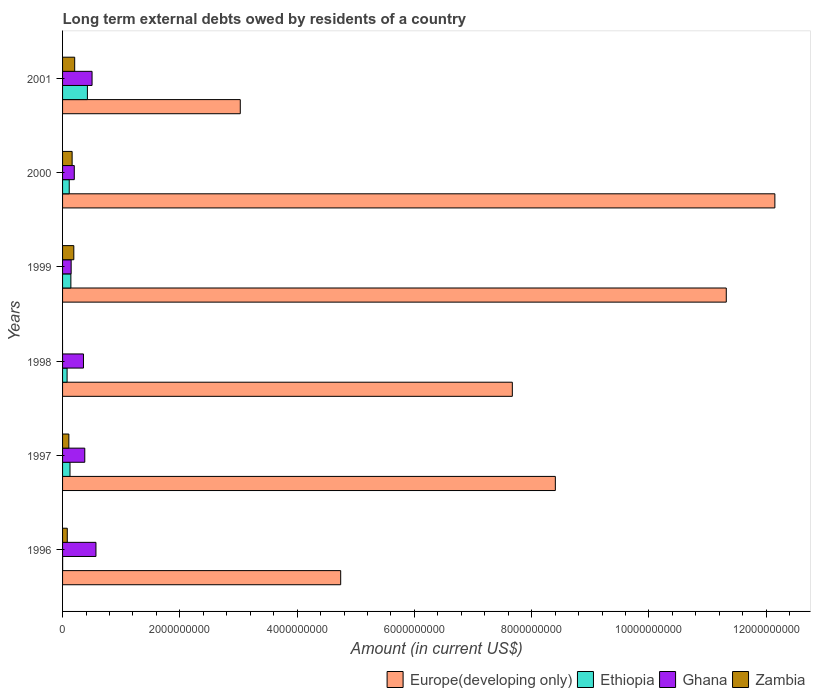How many groups of bars are there?
Offer a very short reply. 6. How many bars are there on the 6th tick from the top?
Keep it short and to the point. 4. How many bars are there on the 3rd tick from the bottom?
Ensure brevity in your answer.  3. Across all years, what is the maximum amount of long-term external debts owed by residents in Ghana?
Keep it short and to the point. 5.69e+08. Across all years, what is the minimum amount of long-term external debts owed by residents in Europe(developing only)?
Your answer should be compact. 3.03e+09. In which year was the amount of long-term external debts owed by residents in Zambia maximum?
Your answer should be very brief. 2001. What is the total amount of long-term external debts owed by residents in Ghana in the graph?
Ensure brevity in your answer.  2.15e+09. What is the difference between the amount of long-term external debts owed by residents in Zambia in 1997 and that in 2001?
Provide a succinct answer. -9.94e+07. What is the difference between the amount of long-term external debts owed by residents in Ethiopia in 2000 and the amount of long-term external debts owed by residents in Europe(developing only) in 1998?
Your answer should be compact. -7.56e+09. What is the average amount of long-term external debts owed by residents in Zambia per year?
Your answer should be very brief. 1.25e+08. In the year 1999, what is the difference between the amount of long-term external debts owed by residents in Europe(developing only) and amount of long-term external debts owed by residents in Ethiopia?
Offer a very short reply. 1.12e+1. In how many years, is the amount of long-term external debts owed by residents in Zambia greater than 5600000000 US$?
Provide a short and direct response. 0. What is the ratio of the amount of long-term external debts owed by residents in Zambia in 1999 to that in 2001?
Provide a succinct answer. 0.93. What is the difference between the highest and the second highest amount of long-term external debts owed by residents in Zambia?
Your response must be concise. 1.48e+07. What is the difference between the highest and the lowest amount of long-term external debts owed by residents in Europe(developing only)?
Keep it short and to the point. 9.12e+09. Is it the case that in every year, the sum of the amount of long-term external debts owed by residents in Europe(developing only) and amount of long-term external debts owed by residents in Ethiopia is greater than the sum of amount of long-term external debts owed by residents in Ghana and amount of long-term external debts owed by residents in Zambia?
Your response must be concise. Yes. Is it the case that in every year, the sum of the amount of long-term external debts owed by residents in Ethiopia and amount of long-term external debts owed by residents in Europe(developing only) is greater than the amount of long-term external debts owed by residents in Ghana?
Give a very brief answer. Yes. What is the difference between two consecutive major ticks on the X-axis?
Make the answer very short. 2.00e+09. Does the graph contain any zero values?
Provide a succinct answer. Yes. What is the title of the graph?
Make the answer very short. Long term external debts owed by residents of a country. Does "Paraguay" appear as one of the legend labels in the graph?
Offer a very short reply. No. What is the label or title of the X-axis?
Provide a short and direct response. Amount (in current US$). What is the label or title of the Y-axis?
Provide a succinct answer. Years. What is the Amount (in current US$) in Europe(developing only) in 1996?
Give a very brief answer. 4.74e+09. What is the Amount (in current US$) of Ethiopia in 1996?
Keep it short and to the point. 8.89e+05. What is the Amount (in current US$) of Ghana in 1996?
Your answer should be compact. 5.69e+08. What is the Amount (in current US$) in Zambia in 1996?
Your response must be concise. 8.04e+07. What is the Amount (in current US$) in Europe(developing only) in 1997?
Give a very brief answer. 8.40e+09. What is the Amount (in current US$) of Ethiopia in 1997?
Make the answer very short. 1.27e+08. What is the Amount (in current US$) of Ghana in 1997?
Provide a short and direct response. 3.79e+08. What is the Amount (in current US$) in Zambia in 1997?
Provide a succinct answer. 1.07e+08. What is the Amount (in current US$) of Europe(developing only) in 1998?
Your answer should be very brief. 7.67e+09. What is the Amount (in current US$) of Ethiopia in 1998?
Keep it short and to the point. 7.71e+07. What is the Amount (in current US$) in Ghana in 1998?
Keep it short and to the point. 3.57e+08. What is the Amount (in current US$) of Europe(developing only) in 1999?
Offer a terse response. 1.13e+1. What is the Amount (in current US$) of Ethiopia in 1999?
Your answer should be very brief. 1.42e+08. What is the Amount (in current US$) of Ghana in 1999?
Your response must be concise. 1.46e+08. What is the Amount (in current US$) of Zambia in 1999?
Your answer should be compact. 1.92e+08. What is the Amount (in current US$) of Europe(developing only) in 2000?
Ensure brevity in your answer.  1.21e+1. What is the Amount (in current US$) of Ethiopia in 2000?
Your response must be concise. 1.14e+08. What is the Amount (in current US$) in Ghana in 2000?
Ensure brevity in your answer.  2.00e+08. What is the Amount (in current US$) of Zambia in 2000?
Give a very brief answer. 1.63e+08. What is the Amount (in current US$) in Europe(developing only) in 2001?
Your answer should be compact. 3.03e+09. What is the Amount (in current US$) of Ethiopia in 2001?
Provide a succinct answer. 4.24e+08. What is the Amount (in current US$) in Ghana in 2001?
Give a very brief answer. 5.03e+08. What is the Amount (in current US$) in Zambia in 2001?
Your answer should be very brief. 2.07e+08. Across all years, what is the maximum Amount (in current US$) in Europe(developing only)?
Provide a succinct answer. 1.21e+1. Across all years, what is the maximum Amount (in current US$) in Ethiopia?
Your answer should be very brief. 4.24e+08. Across all years, what is the maximum Amount (in current US$) in Ghana?
Offer a terse response. 5.69e+08. Across all years, what is the maximum Amount (in current US$) of Zambia?
Give a very brief answer. 2.07e+08. Across all years, what is the minimum Amount (in current US$) of Europe(developing only)?
Offer a terse response. 3.03e+09. Across all years, what is the minimum Amount (in current US$) of Ethiopia?
Offer a very short reply. 8.89e+05. Across all years, what is the minimum Amount (in current US$) in Ghana?
Your response must be concise. 1.46e+08. What is the total Amount (in current US$) in Europe(developing only) in the graph?
Keep it short and to the point. 4.73e+1. What is the total Amount (in current US$) in Ethiopia in the graph?
Ensure brevity in your answer.  8.84e+08. What is the total Amount (in current US$) in Ghana in the graph?
Make the answer very short. 2.15e+09. What is the total Amount (in current US$) in Zambia in the graph?
Keep it short and to the point. 7.49e+08. What is the difference between the Amount (in current US$) in Europe(developing only) in 1996 and that in 1997?
Make the answer very short. -3.66e+09. What is the difference between the Amount (in current US$) of Ethiopia in 1996 and that in 1997?
Your response must be concise. -1.26e+08. What is the difference between the Amount (in current US$) of Ghana in 1996 and that in 1997?
Make the answer very short. 1.91e+08. What is the difference between the Amount (in current US$) of Zambia in 1996 and that in 1997?
Provide a short and direct response. -2.69e+07. What is the difference between the Amount (in current US$) of Europe(developing only) in 1996 and that in 1998?
Your response must be concise. -2.93e+09. What is the difference between the Amount (in current US$) of Ethiopia in 1996 and that in 1998?
Your answer should be compact. -7.62e+07. What is the difference between the Amount (in current US$) in Ghana in 1996 and that in 1998?
Offer a very short reply. 2.13e+08. What is the difference between the Amount (in current US$) of Europe(developing only) in 1996 and that in 1999?
Provide a succinct answer. -6.58e+09. What is the difference between the Amount (in current US$) in Ethiopia in 1996 and that in 1999?
Your response must be concise. -1.41e+08. What is the difference between the Amount (in current US$) of Ghana in 1996 and that in 1999?
Your response must be concise. 4.23e+08. What is the difference between the Amount (in current US$) in Zambia in 1996 and that in 1999?
Your answer should be very brief. -1.11e+08. What is the difference between the Amount (in current US$) in Europe(developing only) in 1996 and that in 2000?
Provide a short and direct response. -7.41e+09. What is the difference between the Amount (in current US$) of Ethiopia in 1996 and that in 2000?
Provide a short and direct response. -1.13e+08. What is the difference between the Amount (in current US$) in Ghana in 1996 and that in 2000?
Give a very brief answer. 3.69e+08. What is the difference between the Amount (in current US$) of Zambia in 1996 and that in 2000?
Give a very brief answer. -8.26e+07. What is the difference between the Amount (in current US$) in Europe(developing only) in 1996 and that in 2001?
Provide a succinct answer. 1.71e+09. What is the difference between the Amount (in current US$) in Ethiopia in 1996 and that in 2001?
Offer a terse response. -4.23e+08. What is the difference between the Amount (in current US$) in Ghana in 1996 and that in 2001?
Ensure brevity in your answer.  6.64e+07. What is the difference between the Amount (in current US$) in Zambia in 1996 and that in 2001?
Make the answer very short. -1.26e+08. What is the difference between the Amount (in current US$) of Europe(developing only) in 1997 and that in 1998?
Ensure brevity in your answer.  7.33e+08. What is the difference between the Amount (in current US$) of Ethiopia in 1997 and that in 1998?
Offer a very short reply. 4.96e+07. What is the difference between the Amount (in current US$) in Ghana in 1997 and that in 1998?
Provide a succinct answer. 2.22e+07. What is the difference between the Amount (in current US$) in Europe(developing only) in 1997 and that in 1999?
Offer a terse response. -2.92e+09. What is the difference between the Amount (in current US$) in Ethiopia in 1997 and that in 1999?
Your answer should be very brief. -1.51e+07. What is the difference between the Amount (in current US$) in Ghana in 1997 and that in 1999?
Give a very brief answer. 2.32e+08. What is the difference between the Amount (in current US$) in Zambia in 1997 and that in 1999?
Make the answer very short. -8.45e+07. What is the difference between the Amount (in current US$) in Europe(developing only) in 1997 and that in 2000?
Your answer should be very brief. -3.74e+09. What is the difference between the Amount (in current US$) in Ethiopia in 1997 and that in 2000?
Your answer should be very brief. 1.30e+07. What is the difference between the Amount (in current US$) of Ghana in 1997 and that in 2000?
Your answer should be compact. 1.79e+08. What is the difference between the Amount (in current US$) of Zambia in 1997 and that in 2000?
Keep it short and to the point. -5.57e+07. What is the difference between the Amount (in current US$) in Europe(developing only) in 1997 and that in 2001?
Make the answer very short. 5.37e+09. What is the difference between the Amount (in current US$) in Ethiopia in 1997 and that in 2001?
Keep it short and to the point. -2.97e+08. What is the difference between the Amount (in current US$) in Ghana in 1997 and that in 2001?
Your answer should be compact. -1.24e+08. What is the difference between the Amount (in current US$) of Zambia in 1997 and that in 2001?
Offer a very short reply. -9.94e+07. What is the difference between the Amount (in current US$) in Europe(developing only) in 1998 and that in 1999?
Provide a short and direct response. -3.65e+09. What is the difference between the Amount (in current US$) in Ethiopia in 1998 and that in 1999?
Your response must be concise. -6.47e+07. What is the difference between the Amount (in current US$) of Ghana in 1998 and that in 1999?
Provide a short and direct response. 2.10e+08. What is the difference between the Amount (in current US$) of Europe(developing only) in 1998 and that in 2000?
Make the answer very short. -4.48e+09. What is the difference between the Amount (in current US$) in Ethiopia in 1998 and that in 2000?
Your answer should be compact. -3.66e+07. What is the difference between the Amount (in current US$) in Ghana in 1998 and that in 2000?
Make the answer very short. 1.57e+08. What is the difference between the Amount (in current US$) of Europe(developing only) in 1998 and that in 2001?
Make the answer very short. 4.64e+09. What is the difference between the Amount (in current US$) in Ethiopia in 1998 and that in 2001?
Keep it short and to the point. -3.46e+08. What is the difference between the Amount (in current US$) in Ghana in 1998 and that in 2001?
Make the answer very short. -1.46e+08. What is the difference between the Amount (in current US$) in Europe(developing only) in 1999 and that in 2000?
Your response must be concise. -8.29e+08. What is the difference between the Amount (in current US$) of Ethiopia in 1999 and that in 2000?
Offer a terse response. 2.81e+07. What is the difference between the Amount (in current US$) of Ghana in 1999 and that in 2000?
Offer a very short reply. -5.35e+07. What is the difference between the Amount (in current US$) in Zambia in 1999 and that in 2000?
Give a very brief answer. 2.88e+07. What is the difference between the Amount (in current US$) of Europe(developing only) in 1999 and that in 2001?
Keep it short and to the point. 8.29e+09. What is the difference between the Amount (in current US$) in Ethiopia in 1999 and that in 2001?
Provide a succinct answer. -2.82e+08. What is the difference between the Amount (in current US$) in Ghana in 1999 and that in 2001?
Provide a succinct answer. -3.57e+08. What is the difference between the Amount (in current US$) in Zambia in 1999 and that in 2001?
Offer a very short reply. -1.48e+07. What is the difference between the Amount (in current US$) of Europe(developing only) in 2000 and that in 2001?
Offer a terse response. 9.12e+09. What is the difference between the Amount (in current US$) of Ethiopia in 2000 and that in 2001?
Provide a short and direct response. -3.10e+08. What is the difference between the Amount (in current US$) in Ghana in 2000 and that in 2001?
Make the answer very short. -3.03e+08. What is the difference between the Amount (in current US$) in Zambia in 2000 and that in 2001?
Make the answer very short. -4.37e+07. What is the difference between the Amount (in current US$) of Europe(developing only) in 1996 and the Amount (in current US$) of Ethiopia in 1997?
Offer a very short reply. 4.62e+09. What is the difference between the Amount (in current US$) of Europe(developing only) in 1996 and the Amount (in current US$) of Ghana in 1997?
Provide a short and direct response. 4.36e+09. What is the difference between the Amount (in current US$) in Europe(developing only) in 1996 and the Amount (in current US$) in Zambia in 1997?
Give a very brief answer. 4.64e+09. What is the difference between the Amount (in current US$) of Ethiopia in 1996 and the Amount (in current US$) of Ghana in 1997?
Provide a succinct answer. -3.78e+08. What is the difference between the Amount (in current US$) in Ethiopia in 1996 and the Amount (in current US$) in Zambia in 1997?
Make the answer very short. -1.06e+08. What is the difference between the Amount (in current US$) of Ghana in 1996 and the Amount (in current US$) of Zambia in 1997?
Your answer should be compact. 4.62e+08. What is the difference between the Amount (in current US$) in Europe(developing only) in 1996 and the Amount (in current US$) in Ethiopia in 1998?
Offer a terse response. 4.67e+09. What is the difference between the Amount (in current US$) of Europe(developing only) in 1996 and the Amount (in current US$) of Ghana in 1998?
Your response must be concise. 4.39e+09. What is the difference between the Amount (in current US$) of Ethiopia in 1996 and the Amount (in current US$) of Ghana in 1998?
Ensure brevity in your answer.  -3.56e+08. What is the difference between the Amount (in current US$) of Europe(developing only) in 1996 and the Amount (in current US$) of Ethiopia in 1999?
Your answer should be compact. 4.60e+09. What is the difference between the Amount (in current US$) in Europe(developing only) in 1996 and the Amount (in current US$) in Ghana in 1999?
Make the answer very short. 4.60e+09. What is the difference between the Amount (in current US$) of Europe(developing only) in 1996 and the Amount (in current US$) of Zambia in 1999?
Your response must be concise. 4.55e+09. What is the difference between the Amount (in current US$) in Ethiopia in 1996 and the Amount (in current US$) in Ghana in 1999?
Make the answer very short. -1.46e+08. What is the difference between the Amount (in current US$) in Ethiopia in 1996 and the Amount (in current US$) in Zambia in 1999?
Provide a short and direct response. -1.91e+08. What is the difference between the Amount (in current US$) in Ghana in 1996 and the Amount (in current US$) in Zambia in 1999?
Your response must be concise. 3.77e+08. What is the difference between the Amount (in current US$) of Europe(developing only) in 1996 and the Amount (in current US$) of Ethiopia in 2000?
Provide a short and direct response. 4.63e+09. What is the difference between the Amount (in current US$) in Europe(developing only) in 1996 and the Amount (in current US$) in Ghana in 2000?
Give a very brief answer. 4.54e+09. What is the difference between the Amount (in current US$) in Europe(developing only) in 1996 and the Amount (in current US$) in Zambia in 2000?
Give a very brief answer. 4.58e+09. What is the difference between the Amount (in current US$) in Ethiopia in 1996 and the Amount (in current US$) in Ghana in 2000?
Provide a short and direct response. -1.99e+08. What is the difference between the Amount (in current US$) in Ethiopia in 1996 and the Amount (in current US$) in Zambia in 2000?
Make the answer very short. -1.62e+08. What is the difference between the Amount (in current US$) of Ghana in 1996 and the Amount (in current US$) of Zambia in 2000?
Ensure brevity in your answer.  4.06e+08. What is the difference between the Amount (in current US$) of Europe(developing only) in 1996 and the Amount (in current US$) of Ethiopia in 2001?
Your answer should be very brief. 4.32e+09. What is the difference between the Amount (in current US$) in Europe(developing only) in 1996 and the Amount (in current US$) in Ghana in 2001?
Your response must be concise. 4.24e+09. What is the difference between the Amount (in current US$) of Europe(developing only) in 1996 and the Amount (in current US$) of Zambia in 2001?
Your answer should be very brief. 4.54e+09. What is the difference between the Amount (in current US$) in Ethiopia in 1996 and the Amount (in current US$) in Ghana in 2001?
Offer a terse response. -5.02e+08. What is the difference between the Amount (in current US$) of Ethiopia in 1996 and the Amount (in current US$) of Zambia in 2001?
Offer a terse response. -2.06e+08. What is the difference between the Amount (in current US$) of Ghana in 1996 and the Amount (in current US$) of Zambia in 2001?
Keep it short and to the point. 3.63e+08. What is the difference between the Amount (in current US$) in Europe(developing only) in 1997 and the Amount (in current US$) in Ethiopia in 1998?
Offer a terse response. 8.33e+09. What is the difference between the Amount (in current US$) of Europe(developing only) in 1997 and the Amount (in current US$) of Ghana in 1998?
Provide a short and direct response. 8.05e+09. What is the difference between the Amount (in current US$) in Ethiopia in 1997 and the Amount (in current US$) in Ghana in 1998?
Your response must be concise. -2.30e+08. What is the difference between the Amount (in current US$) of Europe(developing only) in 1997 and the Amount (in current US$) of Ethiopia in 1999?
Your answer should be very brief. 8.26e+09. What is the difference between the Amount (in current US$) in Europe(developing only) in 1997 and the Amount (in current US$) in Ghana in 1999?
Offer a terse response. 8.26e+09. What is the difference between the Amount (in current US$) of Europe(developing only) in 1997 and the Amount (in current US$) of Zambia in 1999?
Give a very brief answer. 8.21e+09. What is the difference between the Amount (in current US$) in Ethiopia in 1997 and the Amount (in current US$) in Ghana in 1999?
Your answer should be very brief. -1.97e+07. What is the difference between the Amount (in current US$) of Ethiopia in 1997 and the Amount (in current US$) of Zambia in 1999?
Provide a succinct answer. -6.51e+07. What is the difference between the Amount (in current US$) in Ghana in 1997 and the Amount (in current US$) in Zambia in 1999?
Your answer should be compact. 1.87e+08. What is the difference between the Amount (in current US$) in Europe(developing only) in 1997 and the Amount (in current US$) in Ethiopia in 2000?
Make the answer very short. 8.29e+09. What is the difference between the Amount (in current US$) of Europe(developing only) in 1997 and the Amount (in current US$) of Ghana in 2000?
Your response must be concise. 8.20e+09. What is the difference between the Amount (in current US$) in Europe(developing only) in 1997 and the Amount (in current US$) in Zambia in 2000?
Keep it short and to the point. 8.24e+09. What is the difference between the Amount (in current US$) of Ethiopia in 1997 and the Amount (in current US$) of Ghana in 2000?
Keep it short and to the point. -7.31e+07. What is the difference between the Amount (in current US$) of Ethiopia in 1997 and the Amount (in current US$) of Zambia in 2000?
Offer a terse response. -3.63e+07. What is the difference between the Amount (in current US$) in Ghana in 1997 and the Amount (in current US$) in Zambia in 2000?
Keep it short and to the point. 2.16e+08. What is the difference between the Amount (in current US$) of Europe(developing only) in 1997 and the Amount (in current US$) of Ethiopia in 2001?
Your response must be concise. 7.98e+09. What is the difference between the Amount (in current US$) of Europe(developing only) in 1997 and the Amount (in current US$) of Ghana in 2001?
Your response must be concise. 7.90e+09. What is the difference between the Amount (in current US$) of Europe(developing only) in 1997 and the Amount (in current US$) of Zambia in 2001?
Keep it short and to the point. 8.20e+09. What is the difference between the Amount (in current US$) in Ethiopia in 1997 and the Amount (in current US$) in Ghana in 2001?
Give a very brief answer. -3.76e+08. What is the difference between the Amount (in current US$) of Ethiopia in 1997 and the Amount (in current US$) of Zambia in 2001?
Offer a very short reply. -7.99e+07. What is the difference between the Amount (in current US$) in Ghana in 1997 and the Amount (in current US$) in Zambia in 2001?
Keep it short and to the point. 1.72e+08. What is the difference between the Amount (in current US$) in Europe(developing only) in 1998 and the Amount (in current US$) in Ethiopia in 1999?
Provide a short and direct response. 7.53e+09. What is the difference between the Amount (in current US$) of Europe(developing only) in 1998 and the Amount (in current US$) of Ghana in 1999?
Ensure brevity in your answer.  7.52e+09. What is the difference between the Amount (in current US$) in Europe(developing only) in 1998 and the Amount (in current US$) in Zambia in 1999?
Provide a succinct answer. 7.48e+09. What is the difference between the Amount (in current US$) in Ethiopia in 1998 and the Amount (in current US$) in Ghana in 1999?
Offer a terse response. -6.93e+07. What is the difference between the Amount (in current US$) in Ethiopia in 1998 and the Amount (in current US$) in Zambia in 1999?
Give a very brief answer. -1.15e+08. What is the difference between the Amount (in current US$) in Ghana in 1998 and the Amount (in current US$) in Zambia in 1999?
Give a very brief answer. 1.65e+08. What is the difference between the Amount (in current US$) of Europe(developing only) in 1998 and the Amount (in current US$) of Ethiopia in 2000?
Provide a short and direct response. 7.56e+09. What is the difference between the Amount (in current US$) of Europe(developing only) in 1998 and the Amount (in current US$) of Ghana in 2000?
Provide a succinct answer. 7.47e+09. What is the difference between the Amount (in current US$) in Europe(developing only) in 1998 and the Amount (in current US$) in Zambia in 2000?
Provide a short and direct response. 7.51e+09. What is the difference between the Amount (in current US$) of Ethiopia in 1998 and the Amount (in current US$) of Ghana in 2000?
Provide a succinct answer. -1.23e+08. What is the difference between the Amount (in current US$) in Ethiopia in 1998 and the Amount (in current US$) in Zambia in 2000?
Your answer should be very brief. -8.59e+07. What is the difference between the Amount (in current US$) in Ghana in 1998 and the Amount (in current US$) in Zambia in 2000?
Provide a succinct answer. 1.94e+08. What is the difference between the Amount (in current US$) in Europe(developing only) in 1998 and the Amount (in current US$) in Ethiopia in 2001?
Offer a very short reply. 7.25e+09. What is the difference between the Amount (in current US$) in Europe(developing only) in 1998 and the Amount (in current US$) in Ghana in 2001?
Ensure brevity in your answer.  7.17e+09. What is the difference between the Amount (in current US$) in Europe(developing only) in 1998 and the Amount (in current US$) in Zambia in 2001?
Offer a terse response. 7.46e+09. What is the difference between the Amount (in current US$) in Ethiopia in 1998 and the Amount (in current US$) in Ghana in 2001?
Give a very brief answer. -4.26e+08. What is the difference between the Amount (in current US$) in Ethiopia in 1998 and the Amount (in current US$) in Zambia in 2001?
Ensure brevity in your answer.  -1.30e+08. What is the difference between the Amount (in current US$) in Ghana in 1998 and the Amount (in current US$) in Zambia in 2001?
Offer a terse response. 1.50e+08. What is the difference between the Amount (in current US$) of Europe(developing only) in 1999 and the Amount (in current US$) of Ethiopia in 2000?
Your response must be concise. 1.12e+1. What is the difference between the Amount (in current US$) in Europe(developing only) in 1999 and the Amount (in current US$) in Ghana in 2000?
Give a very brief answer. 1.11e+1. What is the difference between the Amount (in current US$) in Europe(developing only) in 1999 and the Amount (in current US$) in Zambia in 2000?
Provide a short and direct response. 1.12e+1. What is the difference between the Amount (in current US$) in Ethiopia in 1999 and the Amount (in current US$) in Ghana in 2000?
Keep it short and to the point. -5.81e+07. What is the difference between the Amount (in current US$) of Ethiopia in 1999 and the Amount (in current US$) of Zambia in 2000?
Your answer should be very brief. -2.12e+07. What is the difference between the Amount (in current US$) in Ghana in 1999 and the Amount (in current US$) in Zambia in 2000?
Your response must be concise. -1.66e+07. What is the difference between the Amount (in current US$) in Europe(developing only) in 1999 and the Amount (in current US$) in Ethiopia in 2001?
Offer a very short reply. 1.09e+1. What is the difference between the Amount (in current US$) of Europe(developing only) in 1999 and the Amount (in current US$) of Ghana in 2001?
Your answer should be compact. 1.08e+1. What is the difference between the Amount (in current US$) of Europe(developing only) in 1999 and the Amount (in current US$) of Zambia in 2001?
Offer a very short reply. 1.11e+1. What is the difference between the Amount (in current US$) of Ethiopia in 1999 and the Amount (in current US$) of Ghana in 2001?
Your response must be concise. -3.61e+08. What is the difference between the Amount (in current US$) of Ethiopia in 1999 and the Amount (in current US$) of Zambia in 2001?
Keep it short and to the point. -6.49e+07. What is the difference between the Amount (in current US$) in Ghana in 1999 and the Amount (in current US$) in Zambia in 2001?
Provide a succinct answer. -6.03e+07. What is the difference between the Amount (in current US$) of Europe(developing only) in 2000 and the Amount (in current US$) of Ethiopia in 2001?
Offer a very short reply. 1.17e+1. What is the difference between the Amount (in current US$) in Europe(developing only) in 2000 and the Amount (in current US$) in Ghana in 2001?
Make the answer very short. 1.16e+1. What is the difference between the Amount (in current US$) of Europe(developing only) in 2000 and the Amount (in current US$) of Zambia in 2001?
Provide a short and direct response. 1.19e+1. What is the difference between the Amount (in current US$) of Ethiopia in 2000 and the Amount (in current US$) of Ghana in 2001?
Offer a terse response. -3.89e+08. What is the difference between the Amount (in current US$) of Ethiopia in 2000 and the Amount (in current US$) of Zambia in 2001?
Offer a very short reply. -9.29e+07. What is the difference between the Amount (in current US$) of Ghana in 2000 and the Amount (in current US$) of Zambia in 2001?
Keep it short and to the point. -6.80e+06. What is the average Amount (in current US$) of Europe(developing only) per year?
Your response must be concise. 7.89e+09. What is the average Amount (in current US$) of Ethiopia per year?
Give a very brief answer. 1.47e+08. What is the average Amount (in current US$) in Ghana per year?
Ensure brevity in your answer.  3.59e+08. What is the average Amount (in current US$) in Zambia per year?
Your answer should be very brief. 1.25e+08. In the year 1996, what is the difference between the Amount (in current US$) of Europe(developing only) and Amount (in current US$) of Ethiopia?
Your response must be concise. 4.74e+09. In the year 1996, what is the difference between the Amount (in current US$) in Europe(developing only) and Amount (in current US$) in Ghana?
Ensure brevity in your answer.  4.17e+09. In the year 1996, what is the difference between the Amount (in current US$) of Europe(developing only) and Amount (in current US$) of Zambia?
Offer a very short reply. 4.66e+09. In the year 1996, what is the difference between the Amount (in current US$) in Ethiopia and Amount (in current US$) in Ghana?
Keep it short and to the point. -5.68e+08. In the year 1996, what is the difference between the Amount (in current US$) in Ethiopia and Amount (in current US$) in Zambia?
Your answer should be compact. -7.95e+07. In the year 1996, what is the difference between the Amount (in current US$) in Ghana and Amount (in current US$) in Zambia?
Make the answer very short. 4.89e+08. In the year 1997, what is the difference between the Amount (in current US$) of Europe(developing only) and Amount (in current US$) of Ethiopia?
Your answer should be very brief. 8.28e+09. In the year 1997, what is the difference between the Amount (in current US$) of Europe(developing only) and Amount (in current US$) of Ghana?
Make the answer very short. 8.03e+09. In the year 1997, what is the difference between the Amount (in current US$) in Europe(developing only) and Amount (in current US$) in Zambia?
Provide a succinct answer. 8.30e+09. In the year 1997, what is the difference between the Amount (in current US$) in Ethiopia and Amount (in current US$) in Ghana?
Make the answer very short. -2.52e+08. In the year 1997, what is the difference between the Amount (in current US$) of Ethiopia and Amount (in current US$) of Zambia?
Your answer should be compact. 1.94e+07. In the year 1997, what is the difference between the Amount (in current US$) in Ghana and Amount (in current US$) in Zambia?
Offer a very short reply. 2.71e+08. In the year 1998, what is the difference between the Amount (in current US$) of Europe(developing only) and Amount (in current US$) of Ethiopia?
Make the answer very short. 7.59e+09. In the year 1998, what is the difference between the Amount (in current US$) in Europe(developing only) and Amount (in current US$) in Ghana?
Offer a very short reply. 7.31e+09. In the year 1998, what is the difference between the Amount (in current US$) in Ethiopia and Amount (in current US$) in Ghana?
Give a very brief answer. -2.79e+08. In the year 1999, what is the difference between the Amount (in current US$) of Europe(developing only) and Amount (in current US$) of Ethiopia?
Your response must be concise. 1.12e+1. In the year 1999, what is the difference between the Amount (in current US$) in Europe(developing only) and Amount (in current US$) in Ghana?
Make the answer very short. 1.12e+1. In the year 1999, what is the difference between the Amount (in current US$) of Europe(developing only) and Amount (in current US$) of Zambia?
Your answer should be compact. 1.11e+1. In the year 1999, what is the difference between the Amount (in current US$) in Ethiopia and Amount (in current US$) in Ghana?
Ensure brevity in your answer.  -4.60e+06. In the year 1999, what is the difference between the Amount (in current US$) of Ethiopia and Amount (in current US$) of Zambia?
Provide a short and direct response. -5.00e+07. In the year 1999, what is the difference between the Amount (in current US$) in Ghana and Amount (in current US$) in Zambia?
Provide a short and direct response. -4.54e+07. In the year 2000, what is the difference between the Amount (in current US$) in Europe(developing only) and Amount (in current US$) in Ethiopia?
Your answer should be compact. 1.20e+1. In the year 2000, what is the difference between the Amount (in current US$) of Europe(developing only) and Amount (in current US$) of Ghana?
Offer a very short reply. 1.19e+1. In the year 2000, what is the difference between the Amount (in current US$) in Europe(developing only) and Amount (in current US$) in Zambia?
Provide a succinct answer. 1.20e+1. In the year 2000, what is the difference between the Amount (in current US$) of Ethiopia and Amount (in current US$) of Ghana?
Your response must be concise. -8.61e+07. In the year 2000, what is the difference between the Amount (in current US$) of Ethiopia and Amount (in current US$) of Zambia?
Your answer should be very brief. -4.93e+07. In the year 2000, what is the difference between the Amount (in current US$) in Ghana and Amount (in current US$) in Zambia?
Keep it short and to the point. 3.69e+07. In the year 2001, what is the difference between the Amount (in current US$) of Europe(developing only) and Amount (in current US$) of Ethiopia?
Provide a succinct answer. 2.61e+09. In the year 2001, what is the difference between the Amount (in current US$) in Europe(developing only) and Amount (in current US$) in Ghana?
Provide a succinct answer. 2.53e+09. In the year 2001, what is the difference between the Amount (in current US$) of Europe(developing only) and Amount (in current US$) of Zambia?
Ensure brevity in your answer.  2.82e+09. In the year 2001, what is the difference between the Amount (in current US$) in Ethiopia and Amount (in current US$) in Ghana?
Give a very brief answer. -7.94e+07. In the year 2001, what is the difference between the Amount (in current US$) of Ethiopia and Amount (in current US$) of Zambia?
Offer a very short reply. 2.17e+08. In the year 2001, what is the difference between the Amount (in current US$) in Ghana and Amount (in current US$) in Zambia?
Your answer should be very brief. 2.96e+08. What is the ratio of the Amount (in current US$) of Europe(developing only) in 1996 to that in 1997?
Your answer should be compact. 0.56. What is the ratio of the Amount (in current US$) of Ethiopia in 1996 to that in 1997?
Your answer should be very brief. 0.01. What is the ratio of the Amount (in current US$) in Ghana in 1996 to that in 1997?
Provide a short and direct response. 1.5. What is the ratio of the Amount (in current US$) of Zambia in 1996 to that in 1997?
Provide a short and direct response. 0.75. What is the ratio of the Amount (in current US$) of Europe(developing only) in 1996 to that in 1998?
Offer a terse response. 0.62. What is the ratio of the Amount (in current US$) in Ethiopia in 1996 to that in 1998?
Offer a very short reply. 0.01. What is the ratio of the Amount (in current US$) of Ghana in 1996 to that in 1998?
Give a very brief answer. 1.6. What is the ratio of the Amount (in current US$) in Europe(developing only) in 1996 to that in 1999?
Keep it short and to the point. 0.42. What is the ratio of the Amount (in current US$) in Ethiopia in 1996 to that in 1999?
Make the answer very short. 0.01. What is the ratio of the Amount (in current US$) in Ghana in 1996 to that in 1999?
Ensure brevity in your answer.  3.89. What is the ratio of the Amount (in current US$) in Zambia in 1996 to that in 1999?
Your answer should be very brief. 0.42. What is the ratio of the Amount (in current US$) of Europe(developing only) in 1996 to that in 2000?
Offer a terse response. 0.39. What is the ratio of the Amount (in current US$) in Ethiopia in 1996 to that in 2000?
Your answer should be very brief. 0.01. What is the ratio of the Amount (in current US$) of Ghana in 1996 to that in 2000?
Ensure brevity in your answer.  2.85. What is the ratio of the Amount (in current US$) in Zambia in 1996 to that in 2000?
Provide a succinct answer. 0.49. What is the ratio of the Amount (in current US$) in Europe(developing only) in 1996 to that in 2001?
Provide a succinct answer. 1.56. What is the ratio of the Amount (in current US$) of Ethiopia in 1996 to that in 2001?
Offer a terse response. 0. What is the ratio of the Amount (in current US$) of Ghana in 1996 to that in 2001?
Provide a short and direct response. 1.13. What is the ratio of the Amount (in current US$) of Zambia in 1996 to that in 2001?
Your answer should be very brief. 0.39. What is the ratio of the Amount (in current US$) of Europe(developing only) in 1997 to that in 1998?
Your answer should be compact. 1.1. What is the ratio of the Amount (in current US$) of Ethiopia in 1997 to that in 1998?
Make the answer very short. 1.64. What is the ratio of the Amount (in current US$) of Ghana in 1997 to that in 1998?
Give a very brief answer. 1.06. What is the ratio of the Amount (in current US$) of Europe(developing only) in 1997 to that in 1999?
Provide a succinct answer. 0.74. What is the ratio of the Amount (in current US$) in Ethiopia in 1997 to that in 1999?
Provide a short and direct response. 0.89. What is the ratio of the Amount (in current US$) in Ghana in 1997 to that in 1999?
Give a very brief answer. 2.59. What is the ratio of the Amount (in current US$) in Zambia in 1997 to that in 1999?
Keep it short and to the point. 0.56. What is the ratio of the Amount (in current US$) in Europe(developing only) in 1997 to that in 2000?
Keep it short and to the point. 0.69. What is the ratio of the Amount (in current US$) of Ethiopia in 1997 to that in 2000?
Your answer should be compact. 1.11. What is the ratio of the Amount (in current US$) of Ghana in 1997 to that in 2000?
Your answer should be compact. 1.9. What is the ratio of the Amount (in current US$) in Zambia in 1997 to that in 2000?
Your answer should be very brief. 0.66. What is the ratio of the Amount (in current US$) of Europe(developing only) in 1997 to that in 2001?
Ensure brevity in your answer.  2.77. What is the ratio of the Amount (in current US$) in Ethiopia in 1997 to that in 2001?
Your answer should be compact. 0.3. What is the ratio of the Amount (in current US$) of Ghana in 1997 to that in 2001?
Your answer should be very brief. 0.75. What is the ratio of the Amount (in current US$) in Zambia in 1997 to that in 2001?
Provide a succinct answer. 0.52. What is the ratio of the Amount (in current US$) in Europe(developing only) in 1998 to that in 1999?
Offer a terse response. 0.68. What is the ratio of the Amount (in current US$) in Ethiopia in 1998 to that in 1999?
Provide a short and direct response. 0.54. What is the ratio of the Amount (in current US$) of Ghana in 1998 to that in 1999?
Offer a very short reply. 2.44. What is the ratio of the Amount (in current US$) in Europe(developing only) in 1998 to that in 2000?
Your response must be concise. 0.63. What is the ratio of the Amount (in current US$) in Ethiopia in 1998 to that in 2000?
Offer a terse response. 0.68. What is the ratio of the Amount (in current US$) of Ghana in 1998 to that in 2000?
Ensure brevity in your answer.  1.78. What is the ratio of the Amount (in current US$) in Europe(developing only) in 1998 to that in 2001?
Your answer should be very brief. 2.53. What is the ratio of the Amount (in current US$) of Ethiopia in 1998 to that in 2001?
Give a very brief answer. 0.18. What is the ratio of the Amount (in current US$) of Ghana in 1998 to that in 2001?
Your answer should be compact. 0.71. What is the ratio of the Amount (in current US$) in Europe(developing only) in 1999 to that in 2000?
Offer a very short reply. 0.93. What is the ratio of the Amount (in current US$) of Ethiopia in 1999 to that in 2000?
Ensure brevity in your answer.  1.25. What is the ratio of the Amount (in current US$) in Ghana in 1999 to that in 2000?
Keep it short and to the point. 0.73. What is the ratio of the Amount (in current US$) in Zambia in 1999 to that in 2000?
Make the answer very short. 1.18. What is the ratio of the Amount (in current US$) of Europe(developing only) in 1999 to that in 2001?
Provide a succinct answer. 3.73. What is the ratio of the Amount (in current US$) of Ethiopia in 1999 to that in 2001?
Provide a succinct answer. 0.33. What is the ratio of the Amount (in current US$) in Ghana in 1999 to that in 2001?
Keep it short and to the point. 0.29. What is the ratio of the Amount (in current US$) of Zambia in 1999 to that in 2001?
Give a very brief answer. 0.93. What is the ratio of the Amount (in current US$) in Europe(developing only) in 2000 to that in 2001?
Your response must be concise. 4.01. What is the ratio of the Amount (in current US$) of Ethiopia in 2000 to that in 2001?
Provide a short and direct response. 0.27. What is the ratio of the Amount (in current US$) of Ghana in 2000 to that in 2001?
Keep it short and to the point. 0.4. What is the ratio of the Amount (in current US$) in Zambia in 2000 to that in 2001?
Ensure brevity in your answer.  0.79. What is the difference between the highest and the second highest Amount (in current US$) in Europe(developing only)?
Make the answer very short. 8.29e+08. What is the difference between the highest and the second highest Amount (in current US$) of Ethiopia?
Your response must be concise. 2.82e+08. What is the difference between the highest and the second highest Amount (in current US$) in Ghana?
Provide a short and direct response. 6.64e+07. What is the difference between the highest and the second highest Amount (in current US$) in Zambia?
Offer a terse response. 1.48e+07. What is the difference between the highest and the lowest Amount (in current US$) of Europe(developing only)?
Provide a short and direct response. 9.12e+09. What is the difference between the highest and the lowest Amount (in current US$) of Ethiopia?
Make the answer very short. 4.23e+08. What is the difference between the highest and the lowest Amount (in current US$) in Ghana?
Your response must be concise. 4.23e+08. What is the difference between the highest and the lowest Amount (in current US$) of Zambia?
Your answer should be compact. 2.07e+08. 